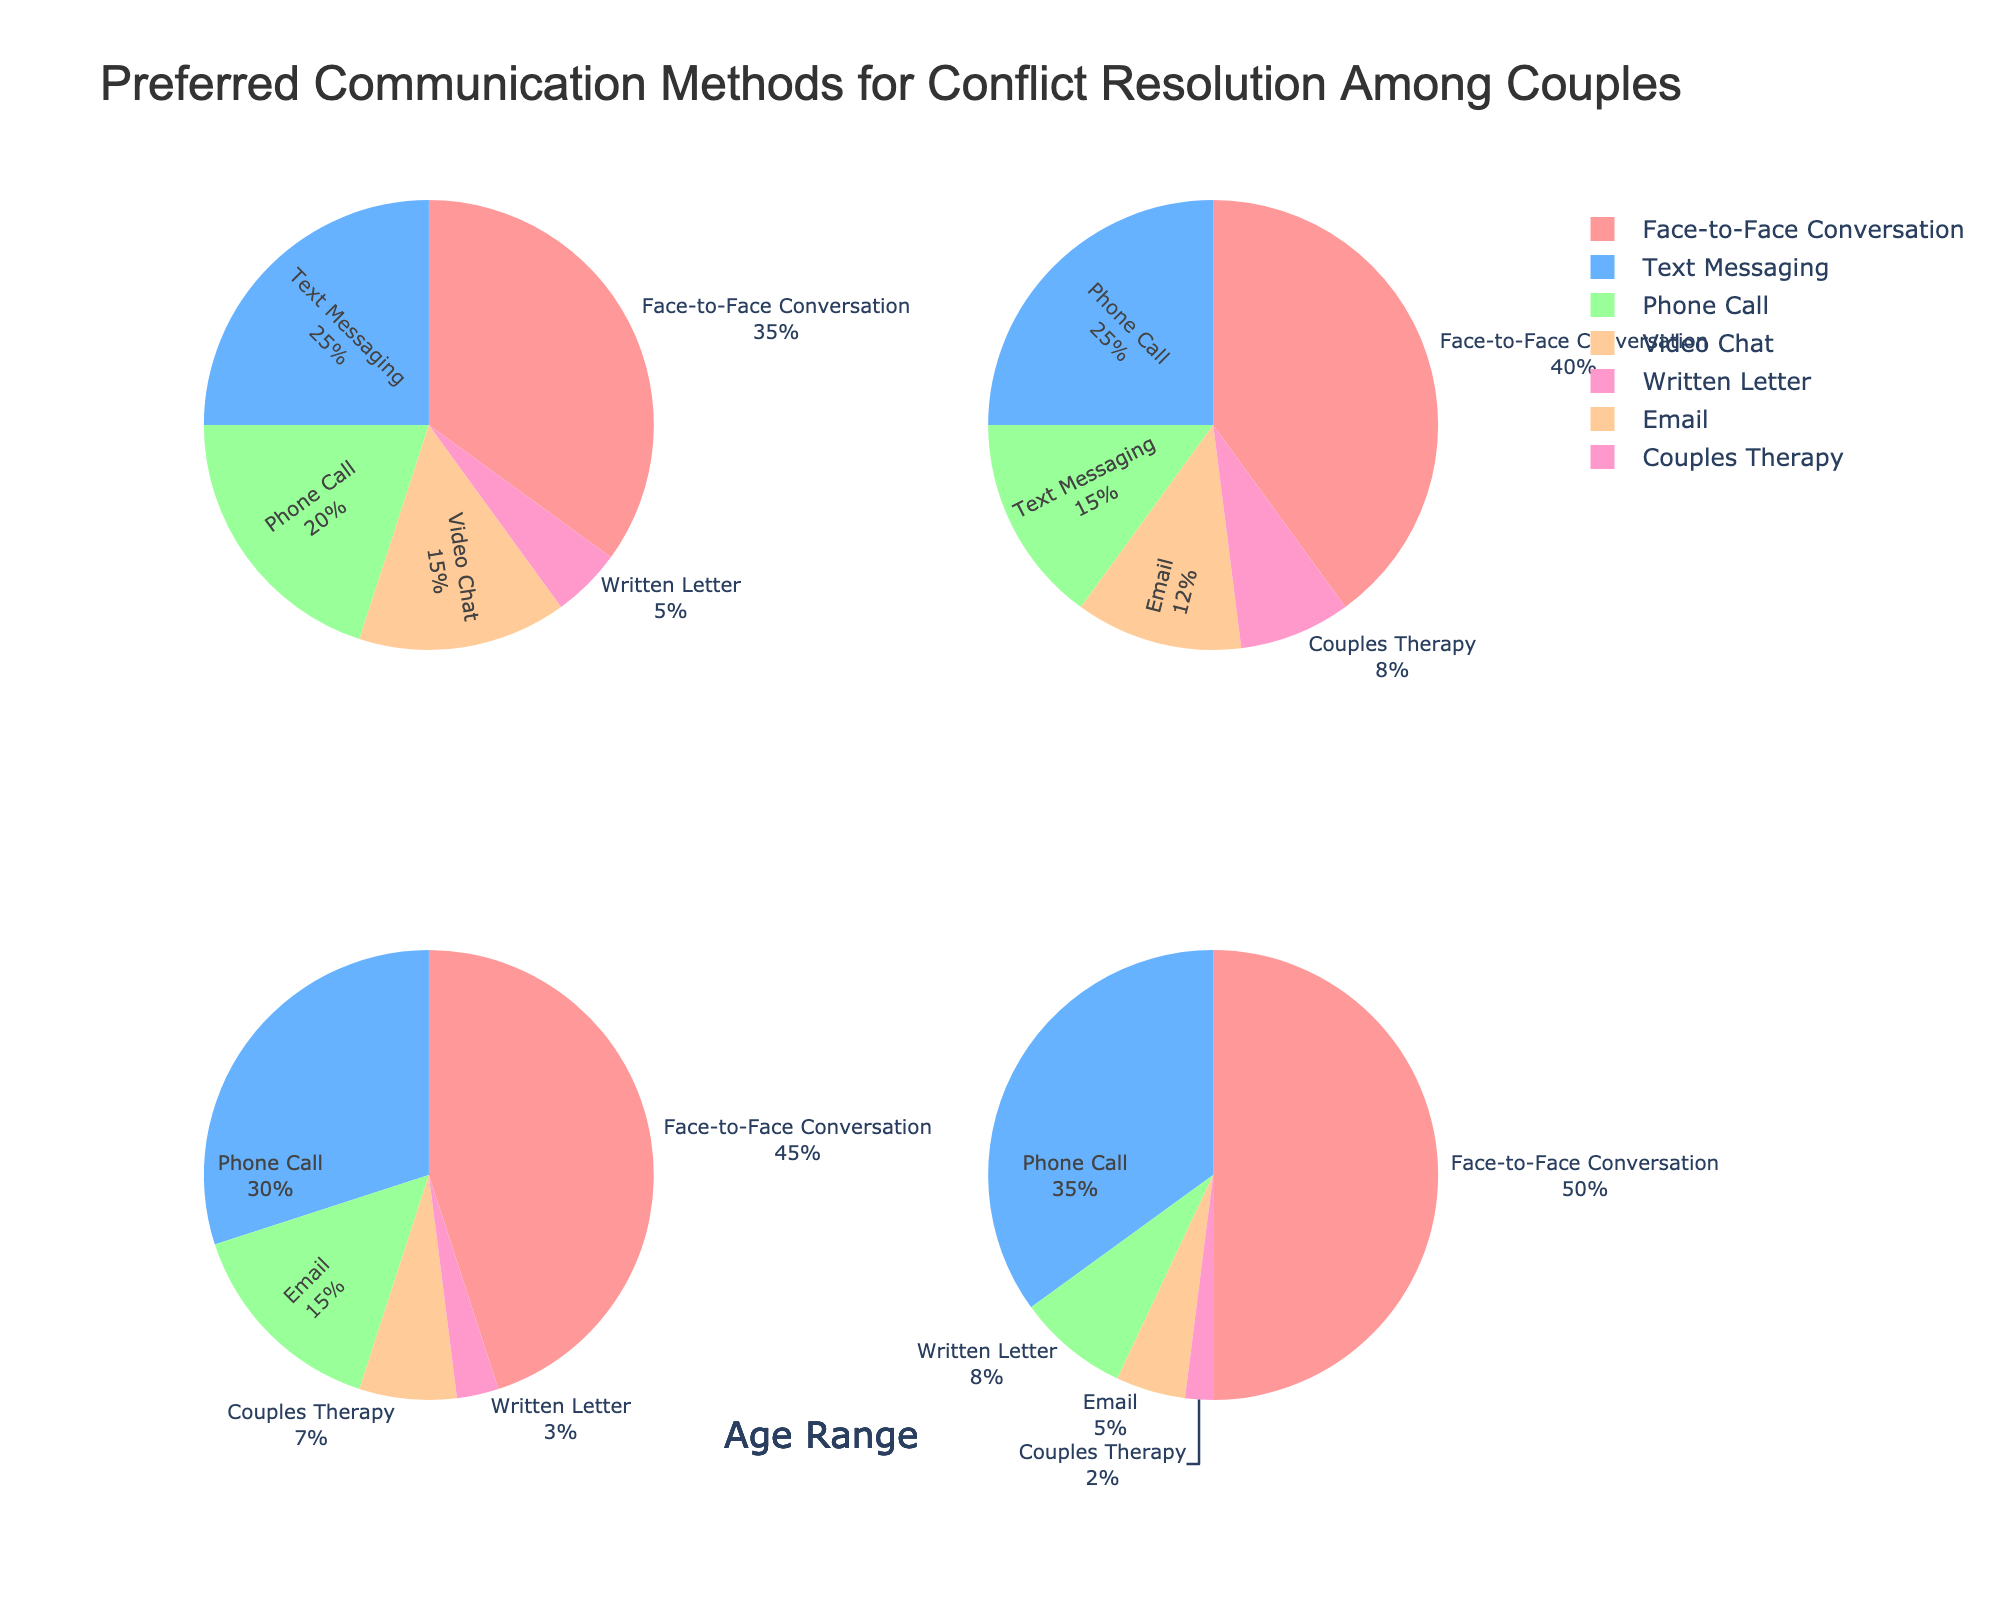What is the most preferred communication method for conflict resolution among couples aged 61+? According to the pie chart, the largest section for the age range 61+ is "Face-to-Face Conversation" at 50%.
Answer: Face-to-Face Conversation How does the preference for phone calls compare between couples aged 31-45 and those aged 46-60? The pie chart shows that couples aged 31-45 prefer phone calls 25% of the time, while couples aged 46-60 prefer them 30% of the time.
Answer: Higher for 46-60 Which age range has the highest percentage of couples using text messaging for conflict resolution? The pie chart indicates that the age range 18-30 has the highest percentage for text messaging at 25%.
Answer: 18-30 What is the sum of the percentages of couples who prefer written letters and email in the 46-60 age range? For the age range 46-60, written letters have 3% and email has 15%. Summing these values gives 3% + 15% = 18%.
Answer: 18% Which communication method is least preferred by couples aged 18-30? The pie chart for couples aged 18-30 shows that the smallest section is for "Written Letter" at 5%.
Answer: Written Letter Compare the preference for couples therapy between couples aged 31-45 and those aged 61+. The pie chart shows that couples aged 31-45 prefer couples therapy 8% of the time, but couples aged 61+ prefer it only 2% of the time.
Answer: Higher for 31-45 Is the preference for face-to-face conversations higher for couples aged 46-60 or those aged 18-30? The pie chart shows that face-to-face conversation is preferred 45% of the time by couples aged 46-60 and 35% by those aged 18-30.
Answer: Higher for 46-60 What is the average preference percentage for phone calls across all age ranges? The percentages for phone calls across the age ranges are 20%, 25%, 30%, and 35%. The average is (20 + 25 + 30 + 35) / 4 = 27.5%.
Answer: 27.5% In the 31-45 age range, what is the difference in preference percentage between face-to-face conversations and text messaging? For the age range 31-45, the preference for face-to-face conversations is 40% and for text messaging is 15%. The difference is 40% - 15% = 25%.
Answer: 25% Which age range exhibits the least diversity in preferred communication methods for conflict resolution? The age range 61+ shows the least diversity, as it has the highest percentage for face-to-face conversation (50%) and phone calls (35%), with much smaller percentages for other methods.
Answer: 61+ 